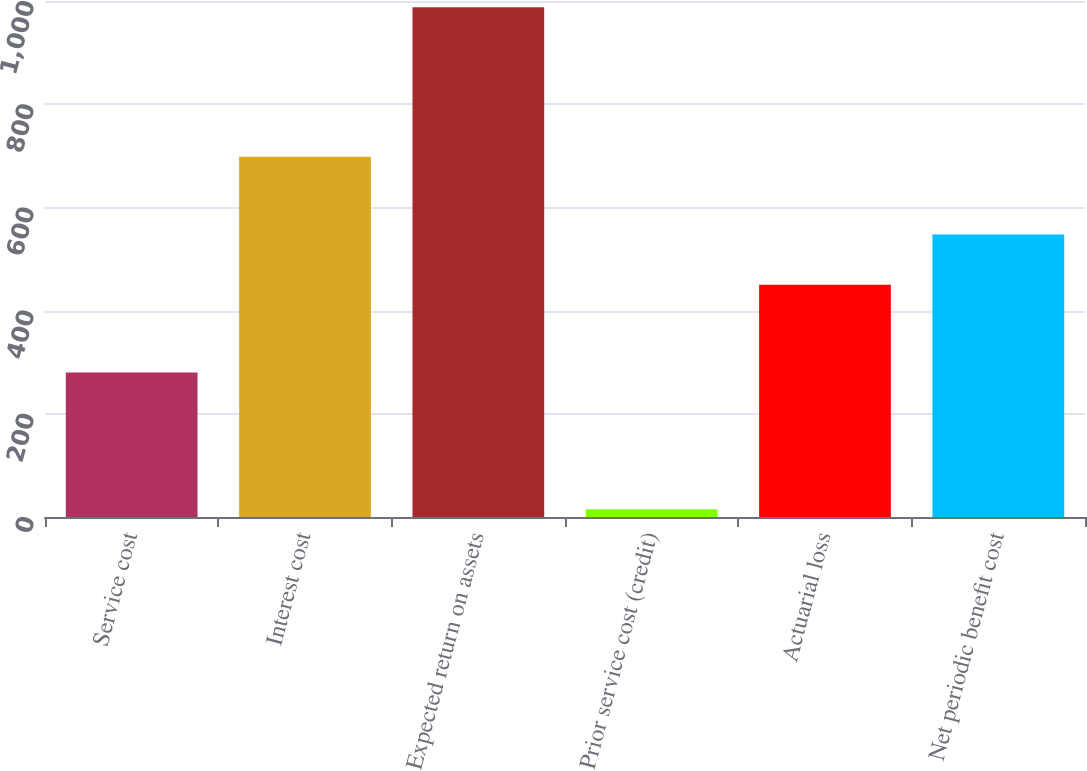Convert chart to OTSL. <chart><loc_0><loc_0><loc_500><loc_500><bar_chart><fcel>Service cost<fcel>Interest cost<fcel>Expected return on assets<fcel>Prior service cost (credit)<fcel>Actuarial loss<fcel>Net periodic benefit cost<nl><fcel>280<fcel>698<fcel>988<fcel>15<fcel>450<fcel>547.3<nl></chart> 